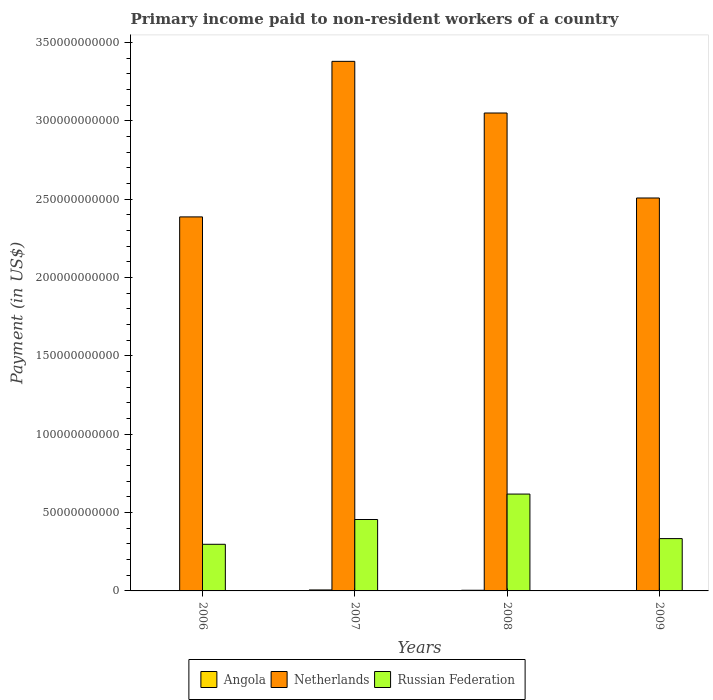How many groups of bars are there?
Offer a terse response. 4. Are the number of bars per tick equal to the number of legend labels?
Your response must be concise. Yes. How many bars are there on the 3rd tick from the left?
Offer a terse response. 3. How many bars are there on the 3rd tick from the right?
Your answer should be compact. 3. What is the amount paid to workers in Russian Federation in 2007?
Make the answer very short. 4.56e+1. Across all years, what is the maximum amount paid to workers in Russian Federation?
Offer a very short reply. 6.18e+1. Across all years, what is the minimum amount paid to workers in Russian Federation?
Your response must be concise. 2.98e+1. In which year was the amount paid to workers in Russian Federation maximum?
Your answer should be compact. 2008. What is the total amount paid to workers in Netherlands in the graph?
Your response must be concise. 1.13e+12. What is the difference between the amount paid to workers in Angola in 2006 and that in 2009?
Keep it short and to the point. 1.37e+07. What is the difference between the amount paid to workers in Russian Federation in 2007 and the amount paid to workers in Netherlands in 2006?
Offer a very short reply. -1.93e+11. What is the average amount paid to workers in Netherlands per year?
Offer a very short reply. 2.83e+11. In the year 2006, what is the difference between the amount paid to workers in Russian Federation and amount paid to workers in Angola?
Provide a succinct answer. 2.96e+1. In how many years, is the amount paid to workers in Angola greater than 50000000000 US$?
Your answer should be very brief. 0. What is the ratio of the amount paid to workers in Angola in 2008 to that in 2009?
Provide a succinct answer. 3.22. Is the amount paid to workers in Netherlands in 2006 less than that in 2007?
Provide a succinct answer. Yes. What is the difference between the highest and the second highest amount paid to workers in Angola?
Your answer should be compact. 2.00e+08. What is the difference between the highest and the lowest amount paid to workers in Netherlands?
Your answer should be very brief. 9.93e+1. What does the 3rd bar from the left in 2008 represents?
Offer a terse response. Russian Federation. What does the 3rd bar from the right in 2007 represents?
Provide a succinct answer. Angola. Are all the bars in the graph horizontal?
Give a very brief answer. No. Are the values on the major ticks of Y-axis written in scientific E-notation?
Make the answer very short. No. Does the graph contain any zero values?
Your answer should be very brief. No. Does the graph contain grids?
Your answer should be compact. No. How are the legend labels stacked?
Keep it short and to the point. Horizontal. What is the title of the graph?
Your response must be concise. Primary income paid to non-resident workers of a country. Does "Brazil" appear as one of the legend labels in the graph?
Keep it short and to the point. No. What is the label or title of the X-axis?
Provide a succinct answer. Years. What is the label or title of the Y-axis?
Provide a succinct answer. Payment (in US$). What is the Payment (in US$) of Angola in 2006?
Your answer should be compact. 1.45e+08. What is the Payment (in US$) in Netherlands in 2006?
Your response must be concise. 2.39e+11. What is the Payment (in US$) of Russian Federation in 2006?
Give a very brief answer. 2.98e+1. What is the Payment (in US$) in Angola in 2007?
Your answer should be very brief. 6.23e+08. What is the Payment (in US$) in Netherlands in 2007?
Your response must be concise. 3.38e+11. What is the Payment (in US$) of Russian Federation in 2007?
Your answer should be compact. 4.56e+1. What is the Payment (in US$) of Angola in 2008?
Keep it short and to the point. 4.22e+08. What is the Payment (in US$) in Netherlands in 2008?
Give a very brief answer. 3.05e+11. What is the Payment (in US$) of Russian Federation in 2008?
Keep it short and to the point. 6.18e+1. What is the Payment (in US$) of Angola in 2009?
Provide a succinct answer. 1.31e+08. What is the Payment (in US$) of Netherlands in 2009?
Offer a very short reply. 2.51e+11. What is the Payment (in US$) of Russian Federation in 2009?
Provide a short and direct response. 3.34e+1. Across all years, what is the maximum Payment (in US$) in Angola?
Your answer should be compact. 6.23e+08. Across all years, what is the maximum Payment (in US$) in Netherlands?
Ensure brevity in your answer.  3.38e+11. Across all years, what is the maximum Payment (in US$) in Russian Federation?
Your answer should be very brief. 6.18e+1. Across all years, what is the minimum Payment (in US$) of Angola?
Provide a short and direct response. 1.31e+08. Across all years, what is the minimum Payment (in US$) of Netherlands?
Offer a terse response. 2.39e+11. Across all years, what is the minimum Payment (in US$) of Russian Federation?
Provide a short and direct response. 2.98e+1. What is the total Payment (in US$) of Angola in the graph?
Offer a terse response. 1.32e+09. What is the total Payment (in US$) in Netherlands in the graph?
Provide a succinct answer. 1.13e+12. What is the total Payment (in US$) in Russian Federation in the graph?
Your response must be concise. 1.71e+11. What is the difference between the Payment (in US$) of Angola in 2006 and that in 2007?
Your answer should be very brief. -4.78e+08. What is the difference between the Payment (in US$) of Netherlands in 2006 and that in 2007?
Ensure brevity in your answer.  -9.93e+1. What is the difference between the Payment (in US$) of Russian Federation in 2006 and that in 2007?
Give a very brief answer. -1.58e+1. What is the difference between the Payment (in US$) of Angola in 2006 and that in 2008?
Provide a short and direct response. -2.77e+08. What is the difference between the Payment (in US$) in Netherlands in 2006 and that in 2008?
Your answer should be compact. -6.63e+1. What is the difference between the Payment (in US$) in Russian Federation in 2006 and that in 2008?
Give a very brief answer. -3.20e+1. What is the difference between the Payment (in US$) in Angola in 2006 and that in 2009?
Your response must be concise. 1.37e+07. What is the difference between the Payment (in US$) of Netherlands in 2006 and that in 2009?
Ensure brevity in your answer.  -1.21e+1. What is the difference between the Payment (in US$) of Russian Federation in 2006 and that in 2009?
Your answer should be very brief. -3.63e+09. What is the difference between the Payment (in US$) of Angola in 2007 and that in 2008?
Provide a short and direct response. 2.00e+08. What is the difference between the Payment (in US$) of Netherlands in 2007 and that in 2008?
Keep it short and to the point. 3.30e+1. What is the difference between the Payment (in US$) in Russian Federation in 2007 and that in 2008?
Offer a very short reply. -1.62e+1. What is the difference between the Payment (in US$) of Angola in 2007 and that in 2009?
Ensure brevity in your answer.  4.91e+08. What is the difference between the Payment (in US$) of Netherlands in 2007 and that in 2009?
Offer a very short reply. 8.72e+1. What is the difference between the Payment (in US$) of Russian Federation in 2007 and that in 2009?
Give a very brief answer. 1.22e+1. What is the difference between the Payment (in US$) of Angola in 2008 and that in 2009?
Give a very brief answer. 2.91e+08. What is the difference between the Payment (in US$) of Netherlands in 2008 and that in 2009?
Give a very brief answer. 5.42e+1. What is the difference between the Payment (in US$) in Russian Federation in 2008 and that in 2009?
Ensure brevity in your answer.  2.84e+1. What is the difference between the Payment (in US$) in Angola in 2006 and the Payment (in US$) in Netherlands in 2007?
Ensure brevity in your answer.  -3.38e+11. What is the difference between the Payment (in US$) in Angola in 2006 and the Payment (in US$) in Russian Federation in 2007?
Provide a short and direct response. -4.54e+1. What is the difference between the Payment (in US$) of Netherlands in 2006 and the Payment (in US$) of Russian Federation in 2007?
Provide a succinct answer. 1.93e+11. What is the difference between the Payment (in US$) of Angola in 2006 and the Payment (in US$) of Netherlands in 2008?
Provide a short and direct response. -3.05e+11. What is the difference between the Payment (in US$) of Angola in 2006 and the Payment (in US$) of Russian Federation in 2008?
Your response must be concise. -6.17e+1. What is the difference between the Payment (in US$) of Netherlands in 2006 and the Payment (in US$) of Russian Federation in 2008?
Give a very brief answer. 1.77e+11. What is the difference between the Payment (in US$) in Angola in 2006 and the Payment (in US$) in Netherlands in 2009?
Keep it short and to the point. -2.51e+11. What is the difference between the Payment (in US$) in Angola in 2006 and the Payment (in US$) in Russian Federation in 2009?
Your response must be concise. -3.33e+1. What is the difference between the Payment (in US$) in Netherlands in 2006 and the Payment (in US$) in Russian Federation in 2009?
Your answer should be very brief. 2.05e+11. What is the difference between the Payment (in US$) of Angola in 2007 and the Payment (in US$) of Netherlands in 2008?
Ensure brevity in your answer.  -3.04e+11. What is the difference between the Payment (in US$) of Angola in 2007 and the Payment (in US$) of Russian Federation in 2008?
Keep it short and to the point. -6.12e+1. What is the difference between the Payment (in US$) of Netherlands in 2007 and the Payment (in US$) of Russian Federation in 2008?
Your response must be concise. 2.76e+11. What is the difference between the Payment (in US$) of Angola in 2007 and the Payment (in US$) of Netherlands in 2009?
Offer a terse response. -2.50e+11. What is the difference between the Payment (in US$) in Angola in 2007 and the Payment (in US$) in Russian Federation in 2009?
Keep it short and to the point. -3.28e+1. What is the difference between the Payment (in US$) in Netherlands in 2007 and the Payment (in US$) in Russian Federation in 2009?
Give a very brief answer. 3.05e+11. What is the difference between the Payment (in US$) in Angola in 2008 and the Payment (in US$) in Netherlands in 2009?
Give a very brief answer. -2.50e+11. What is the difference between the Payment (in US$) in Angola in 2008 and the Payment (in US$) in Russian Federation in 2009?
Your response must be concise. -3.30e+1. What is the difference between the Payment (in US$) in Netherlands in 2008 and the Payment (in US$) in Russian Federation in 2009?
Provide a succinct answer. 2.72e+11. What is the average Payment (in US$) of Angola per year?
Provide a short and direct response. 3.30e+08. What is the average Payment (in US$) of Netherlands per year?
Make the answer very short. 2.83e+11. What is the average Payment (in US$) of Russian Federation per year?
Keep it short and to the point. 4.26e+1. In the year 2006, what is the difference between the Payment (in US$) in Angola and Payment (in US$) in Netherlands?
Your answer should be compact. -2.39e+11. In the year 2006, what is the difference between the Payment (in US$) of Angola and Payment (in US$) of Russian Federation?
Ensure brevity in your answer.  -2.96e+1. In the year 2006, what is the difference between the Payment (in US$) in Netherlands and Payment (in US$) in Russian Federation?
Provide a short and direct response. 2.09e+11. In the year 2007, what is the difference between the Payment (in US$) of Angola and Payment (in US$) of Netherlands?
Make the answer very short. -3.37e+11. In the year 2007, what is the difference between the Payment (in US$) of Angola and Payment (in US$) of Russian Federation?
Give a very brief answer. -4.50e+1. In the year 2007, what is the difference between the Payment (in US$) in Netherlands and Payment (in US$) in Russian Federation?
Make the answer very short. 2.92e+11. In the year 2008, what is the difference between the Payment (in US$) of Angola and Payment (in US$) of Netherlands?
Your response must be concise. -3.05e+11. In the year 2008, what is the difference between the Payment (in US$) of Angola and Payment (in US$) of Russian Federation?
Your answer should be compact. -6.14e+1. In the year 2008, what is the difference between the Payment (in US$) of Netherlands and Payment (in US$) of Russian Federation?
Give a very brief answer. 2.43e+11. In the year 2009, what is the difference between the Payment (in US$) in Angola and Payment (in US$) in Netherlands?
Offer a terse response. -2.51e+11. In the year 2009, what is the difference between the Payment (in US$) of Angola and Payment (in US$) of Russian Federation?
Your response must be concise. -3.33e+1. In the year 2009, what is the difference between the Payment (in US$) in Netherlands and Payment (in US$) in Russian Federation?
Make the answer very short. 2.17e+11. What is the ratio of the Payment (in US$) of Angola in 2006 to that in 2007?
Make the answer very short. 0.23. What is the ratio of the Payment (in US$) in Netherlands in 2006 to that in 2007?
Your answer should be very brief. 0.71. What is the ratio of the Payment (in US$) in Russian Federation in 2006 to that in 2007?
Keep it short and to the point. 0.65. What is the ratio of the Payment (in US$) in Angola in 2006 to that in 2008?
Make the answer very short. 0.34. What is the ratio of the Payment (in US$) in Netherlands in 2006 to that in 2008?
Make the answer very short. 0.78. What is the ratio of the Payment (in US$) of Russian Federation in 2006 to that in 2008?
Your response must be concise. 0.48. What is the ratio of the Payment (in US$) of Angola in 2006 to that in 2009?
Provide a succinct answer. 1.1. What is the ratio of the Payment (in US$) in Netherlands in 2006 to that in 2009?
Keep it short and to the point. 0.95. What is the ratio of the Payment (in US$) of Russian Federation in 2006 to that in 2009?
Your answer should be compact. 0.89. What is the ratio of the Payment (in US$) of Angola in 2007 to that in 2008?
Offer a terse response. 1.47. What is the ratio of the Payment (in US$) in Netherlands in 2007 to that in 2008?
Ensure brevity in your answer.  1.11. What is the ratio of the Payment (in US$) in Russian Federation in 2007 to that in 2008?
Your answer should be compact. 0.74. What is the ratio of the Payment (in US$) in Angola in 2007 to that in 2009?
Your answer should be compact. 4.74. What is the ratio of the Payment (in US$) of Netherlands in 2007 to that in 2009?
Make the answer very short. 1.35. What is the ratio of the Payment (in US$) of Russian Federation in 2007 to that in 2009?
Give a very brief answer. 1.36. What is the ratio of the Payment (in US$) in Angola in 2008 to that in 2009?
Make the answer very short. 3.22. What is the ratio of the Payment (in US$) of Netherlands in 2008 to that in 2009?
Keep it short and to the point. 1.22. What is the ratio of the Payment (in US$) in Russian Federation in 2008 to that in 2009?
Offer a terse response. 1.85. What is the difference between the highest and the second highest Payment (in US$) in Angola?
Your answer should be compact. 2.00e+08. What is the difference between the highest and the second highest Payment (in US$) in Netherlands?
Your answer should be very brief. 3.30e+1. What is the difference between the highest and the second highest Payment (in US$) in Russian Federation?
Your answer should be compact. 1.62e+1. What is the difference between the highest and the lowest Payment (in US$) of Angola?
Make the answer very short. 4.91e+08. What is the difference between the highest and the lowest Payment (in US$) in Netherlands?
Keep it short and to the point. 9.93e+1. What is the difference between the highest and the lowest Payment (in US$) in Russian Federation?
Offer a terse response. 3.20e+1. 